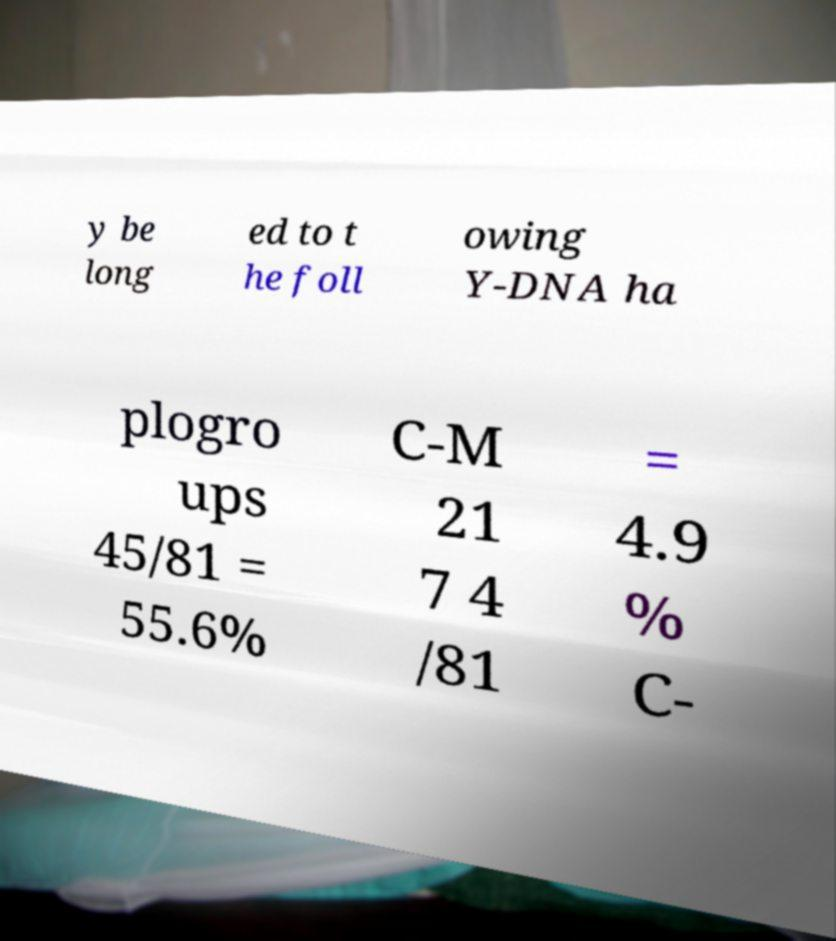Could you extract and type out the text from this image? y be long ed to t he foll owing Y-DNA ha plogro ups 45/81 = 55.6% C-M 21 7 4 /81 = 4.9 % C- 